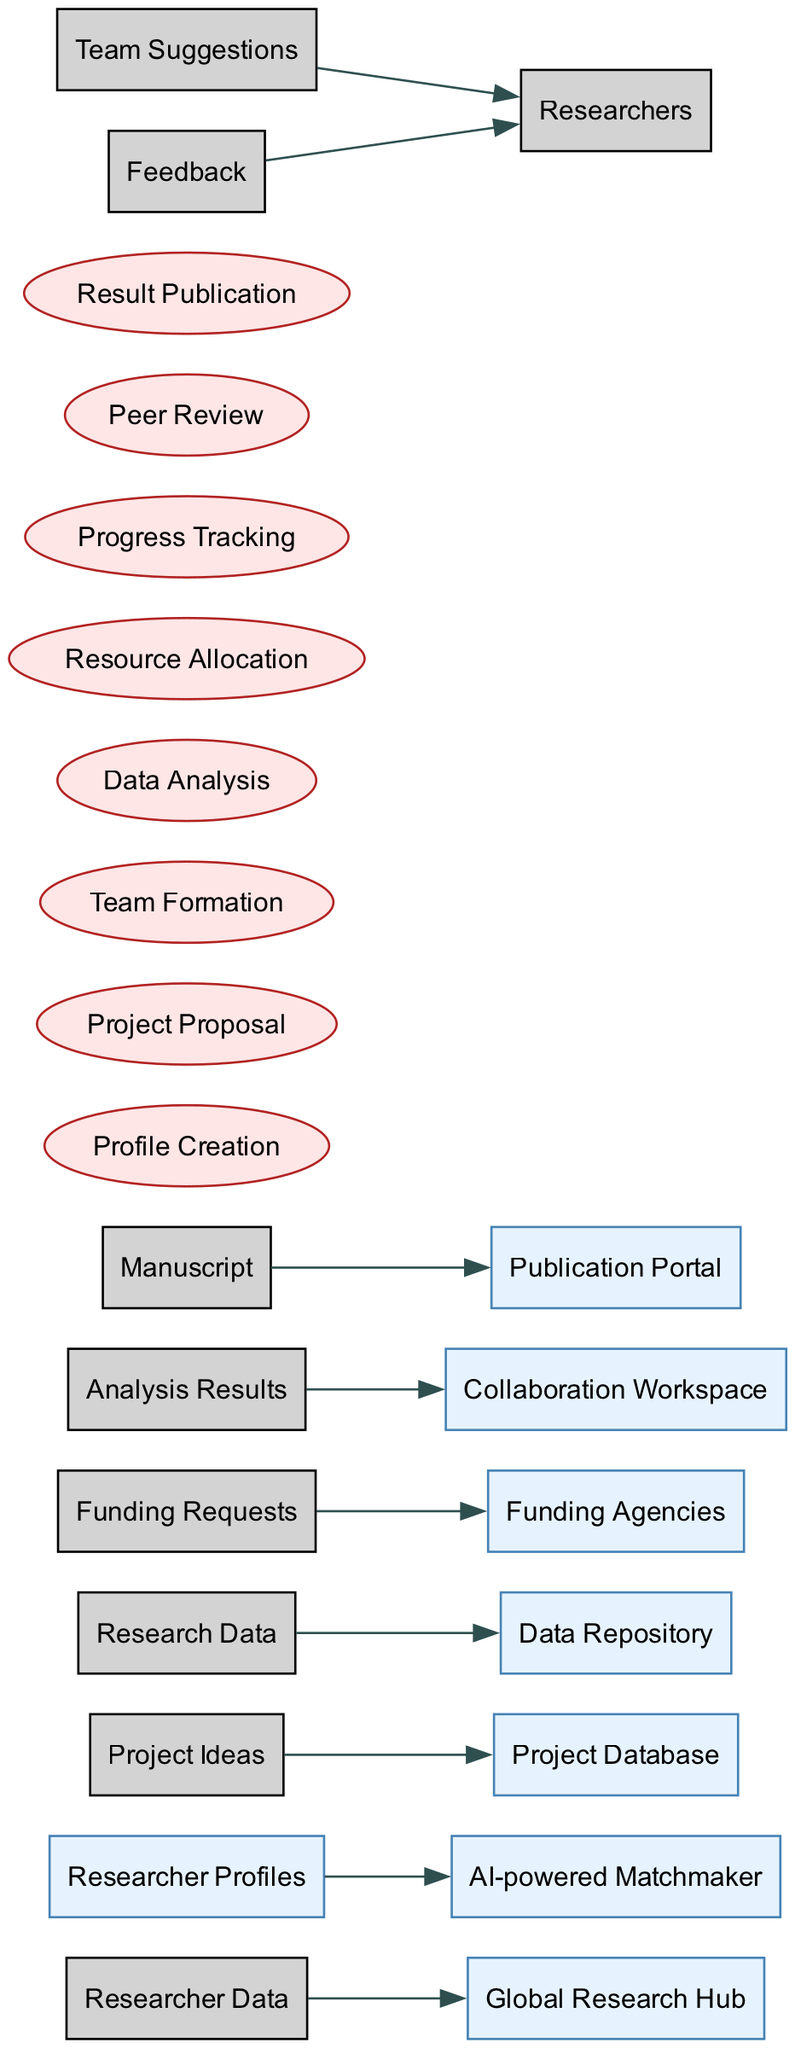What is the number of entities in the diagram? In the diagram, we can identify the entities listed in the 'entities' section: Global Research Hub, Researcher Profiles, Project Database, Data Repository, Funding Agencies, AI-powered Matchmaker, Collaboration Workspace, and Publication Portal. Counting these up gives us 8 entities.
Answer: 8 Which process follows the "Project Proposal" in the workflow? To answer this, we look at the order of processes listed in the 'processes' section. The order is: Profile Creation, Project Proposal, Team Formation, Data Analysis, Resource Allocation, Progress Tracking, Peer Review, and Result Publication. The process immediately following "Project Proposal" is "Team Formation."
Answer: Team Formation What data flows from "Researcher Profiles" to another node? The data flow from "Researcher Profiles" is directed towards the "AI-powered Matchmaker." This is identified by looking at the specific data flows mentioned in the 'dataFlows' section, where we see "Researcher Profiles" leads to the "AI-powered Matchmaker."
Answer: AI-powered Matchmaker How many processes are listed in the diagram? By examining the 'processes' section, we can count the number of listed processes: Profile Creation, Project Proposal, Team Formation, Data Analysis, Resource Allocation, Progress Tracking, Peer Review, Result Publication. Counting these gives us a total of 8 processes.
Answer: 8 Which entity receives "Funding Requests"? Looking at the 'dataFlows' section, we find that "Funding Requests" flow to "Funding Agencies." This indicates that this is where the requests are directed.
Answer: Funding Agencies What is the last process in the workflow? The last process in the 'processes' section of the diagram lists the various processes in order. The final entry is "Result Publication," which means this is the concluding process in the flow.
Answer: Result Publication Which node provides feedback to the researchers? From the 'dataFlows' section, we see that "Feedback" is directed towards "Researchers." This means that the researchers are the recipients of the feedback in the workflow.
Answer: Researchers What type of diagram is this? This is a Data Flow Diagram (DFD), evident from the labeling and the structure showcasing entities, processes, and data flows among them.
Answer: Data Flow Diagram 